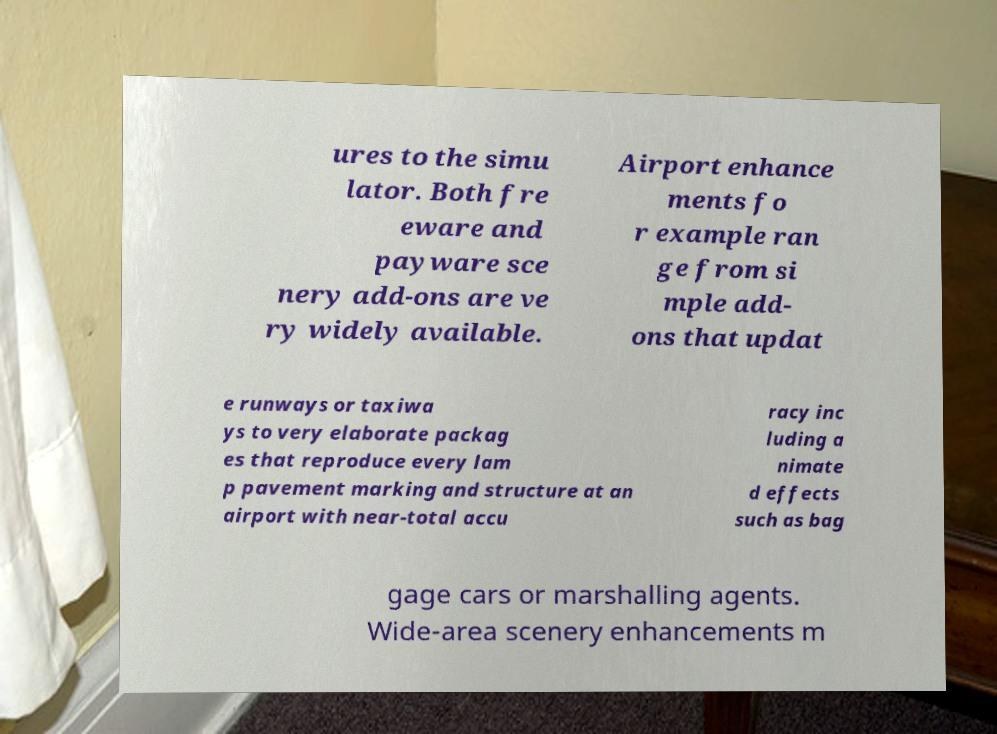Can you read and provide the text displayed in the image?This photo seems to have some interesting text. Can you extract and type it out for me? ures to the simu lator. Both fre eware and payware sce nery add-ons are ve ry widely available. Airport enhance ments fo r example ran ge from si mple add- ons that updat e runways or taxiwa ys to very elaborate packag es that reproduce every lam p pavement marking and structure at an airport with near-total accu racy inc luding a nimate d effects such as bag gage cars or marshalling agents. Wide-area scenery enhancements m 